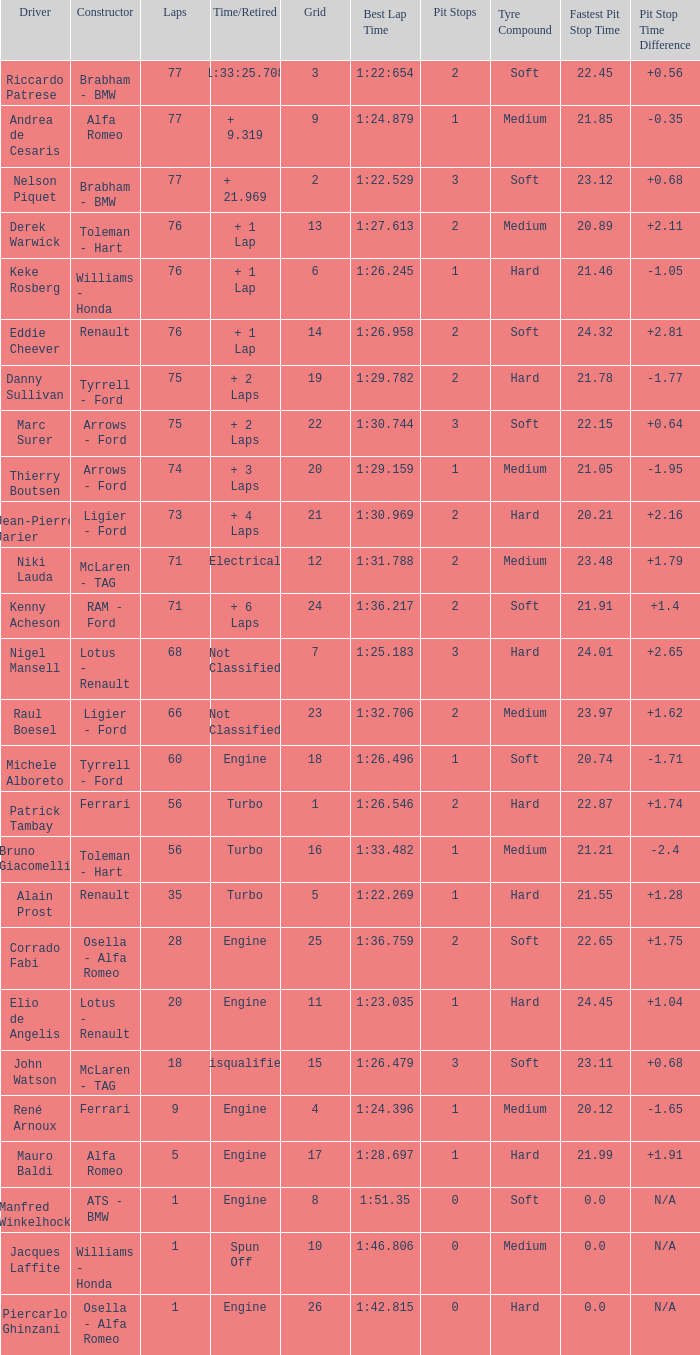I'm looking to parse the entire table for insights. Could you assist me with that? {'header': ['Driver', 'Constructor', 'Laps', 'Time/Retired', 'Grid', 'Best Lap Time', 'Pit Stops', 'Tyre Compound', 'Fastest Pit Stop Time', 'Pit Stop Time Difference'], 'rows': [['Riccardo Patrese', 'Brabham - BMW', '77', '1:33:25.708', '3', '1:22:654', '2', 'Soft', '22.45', '+0.56'], ['Andrea de Cesaris', 'Alfa Romeo', '77', '+ 9.319', '9', '1:24.879', '1', 'Medium', '21.85', '-0.35'], ['Nelson Piquet', 'Brabham - BMW', '77', '+ 21.969', '2', '1:22.529', '3', 'Soft', '23.12', '+0.68'], ['Derek Warwick', 'Toleman - Hart', '76', '+ 1 Lap', '13', '1:27.613', '2', 'Medium', '20.89', '+2.11'], ['Keke Rosberg', 'Williams - Honda', '76', '+ 1 Lap', '6', '1:26.245', '1', 'Hard', '21.46', '-1.05'], ['Eddie Cheever', 'Renault', '76', '+ 1 Lap', '14', '1:26.958', '2', 'Soft', '24.32', '+2.81'], ['Danny Sullivan', 'Tyrrell - Ford', '75', '+ 2 Laps', '19', '1:29.782', '2', 'Hard', '21.78', '-1.77'], ['Marc Surer', 'Arrows - Ford', '75', '+ 2 Laps', '22', '1:30.744', '3', 'Soft', '22.15', '+0.64'], ['Thierry Boutsen', 'Arrows - Ford', '74', '+ 3 Laps', '20', '1:29.159', '1', 'Medium', '21.05', '-1.95'], ['Jean-Pierre Jarier', 'Ligier - Ford', '73', '+ 4 Laps', '21', '1:30.969', '2', 'Hard', '20.21', '+2.16'], ['Niki Lauda', 'McLaren - TAG', '71', 'Electrical', '12', '1:31.788', '2', 'Medium', '23.48', '+1.79'], ['Kenny Acheson', 'RAM - Ford', '71', '+ 6 Laps', '24', '1:36.217', '2', 'Soft', '21.91', '+1.4'], ['Nigel Mansell', 'Lotus - Renault', '68', 'Not Classified', '7', '1:25.183', '3', 'Hard', '24.01', '+2.65'], ['Raul Boesel', 'Ligier - Ford', '66', 'Not Classified', '23', '1:32.706', '2', 'Medium', '23.97', '+1.62'], ['Michele Alboreto', 'Tyrrell - Ford', '60', 'Engine', '18', '1:26.496', '1', 'Soft', '20.74', '-1.71'], ['Patrick Tambay', 'Ferrari', '56', 'Turbo', '1', '1:26.546', '2', 'Hard', '22.87', '+1.74'], ['Bruno Giacomelli', 'Toleman - Hart', '56', 'Turbo', '16', '1:33.482', '1', 'Medium', '21.21', '-2.4'], ['Alain Prost', 'Renault', '35', 'Turbo', '5', '1:22.269', '1', 'Hard', '21.55', '+1.28'], ['Corrado Fabi', 'Osella - Alfa Romeo', '28', 'Engine', '25', '1:36.759', '2', 'Soft', '22.65', '+1.75'], ['Elio de Angelis', 'Lotus - Renault', '20', 'Engine', '11', '1:23.035', '1', 'Hard', '24.45', '+1.04'], ['John Watson', 'McLaren - TAG', '18', 'Disqualified', '15', '1:26.479', '3', 'Soft', '23.11', '+0.68'], ['René Arnoux', 'Ferrari', '9', 'Engine', '4', '1:24.396', '1', 'Medium', '20.12', '-1.65'], ['Mauro Baldi', 'Alfa Romeo', '5', 'Engine', '17', '1:28.697', '1', 'Hard', '21.99', '+1.91'], ['Manfred Winkelhock', 'ATS - BMW', '1', 'Engine', '8', '1:51.35', '0', 'Soft', '0.0', 'N/A'], ['Jacques Laffite', 'Williams - Honda', '1', 'Spun Off', '10', '1:46.806', '0', 'Medium', '0.0', 'N/A'], ['Piercarlo Ghinzani', 'Osella - Alfa Romeo', '1', 'Engine', '26', '1:42.815', '0', 'Hard', '0.0', 'N/A']]} Who drive the car that went under 60 laps and spun off? Jacques Laffite. 